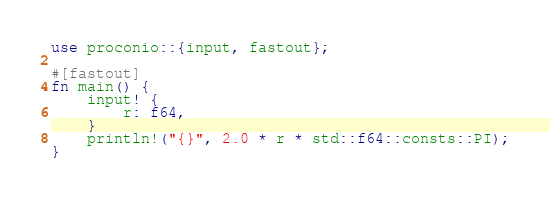Convert code to text. <code><loc_0><loc_0><loc_500><loc_500><_Rust_>use proconio::{input, fastout};

#[fastout]
fn main() {
    input! {
        r: f64,
    }
    println!("{}", 2.0 * r * std::f64::consts::PI);
}
</code> 